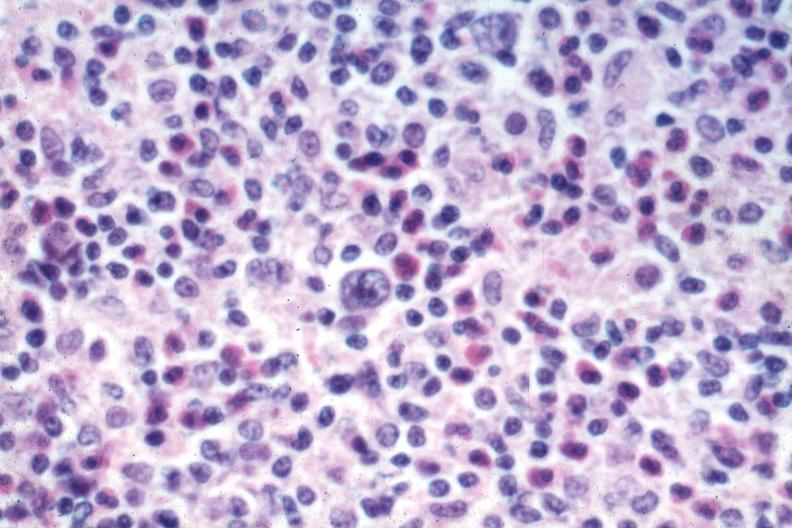s hodgkins disease present?
Answer the question using a single word or phrase. Yes 